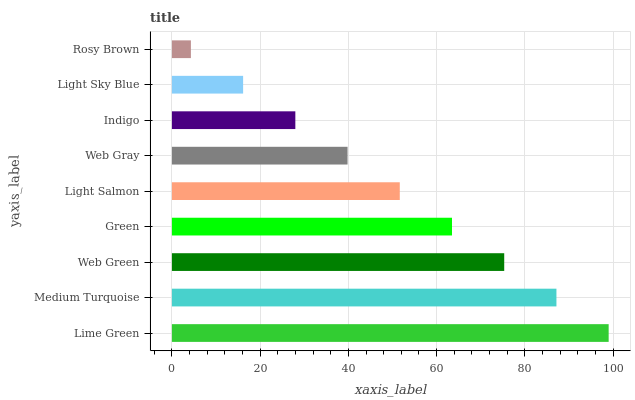Is Rosy Brown the minimum?
Answer yes or no. Yes. Is Lime Green the maximum?
Answer yes or no. Yes. Is Medium Turquoise the minimum?
Answer yes or no. No. Is Medium Turquoise the maximum?
Answer yes or no. No. Is Lime Green greater than Medium Turquoise?
Answer yes or no. Yes. Is Medium Turquoise less than Lime Green?
Answer yes or no. Yes. Is Medium Turquoise greater than Lime Green?
Answer yes or no. No. Is Lime Green less than Medium Turquoise?
Answer yes or no. No. Is Light Salmon the high median?
Answer yes or no. Yes. Is Light Salmon the low median?
Answer yes or no. Yes. Is Indigo the high median?
Answer yes or no. No. Is Web Green the low median?
Answer yes or no. No. 